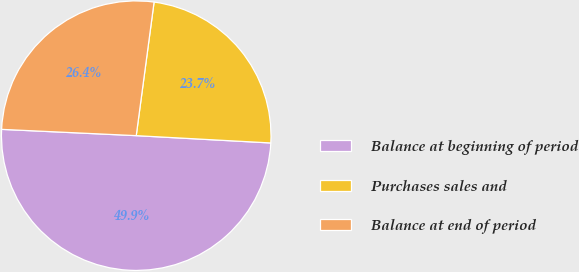<chart> <loc_0><loc_0><loc_500><loc_500><pie_chart><fcel>Balance at beginning of period<fcel>Purchases sales and<fcel>Balance at end of period<nl><fcel>49.88%<fcel>23.75%<fcel>26.37%<nl></chart> 